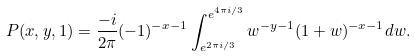<formula> <loc_0><loc_0><loc_500><loc_500>P ( x , y , 1 ) = \frac { - i } { 2 \pi } ( - 1 ) ^ { - x - 1 } \int _ { e ^ { 2 \pi i / 3 } } ^ { e ^ { 4 \pi i / 3 } } w ^ { - y - 1 } ( 1 + w ) ^ { - x - 1 } d w .</formula> 